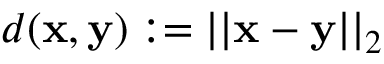Convert formula to latex. <formula><loc_0><loc_0><loc_500><loc_500>d ( x , y ) \colon = | | x - y | | _ { 2 }</formula> 